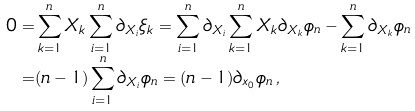Convert formula to latex. <formula><loc_0><loc_0><loc_500><loc_500>0 = & \sum _ { k = 1 } ^ { n } X _ { k } \sum _ { i = 1 } ^ { n } \partial _ { X _ { i } } \xi _ { k } = \sum _ { i = 1 } ^ { n } \partial _ { X _ { i } } \sum _ { k = 1 } ^ { n } X _ { k } \partial _ { X _ { k } } \phi _ { n } - \sum _ { k = 1 } ^ { n } \partial _ { X _ { k } } \phi _ { n } \\ = & ( n - 1 ) \sum _ { i = 1 } ^ { n } \partial _ { X _ { i } } \phi _ { n } = ( n - 1 ) \partial _ { x _ { 0 } } \phi _ { n } \, ,</formula> 